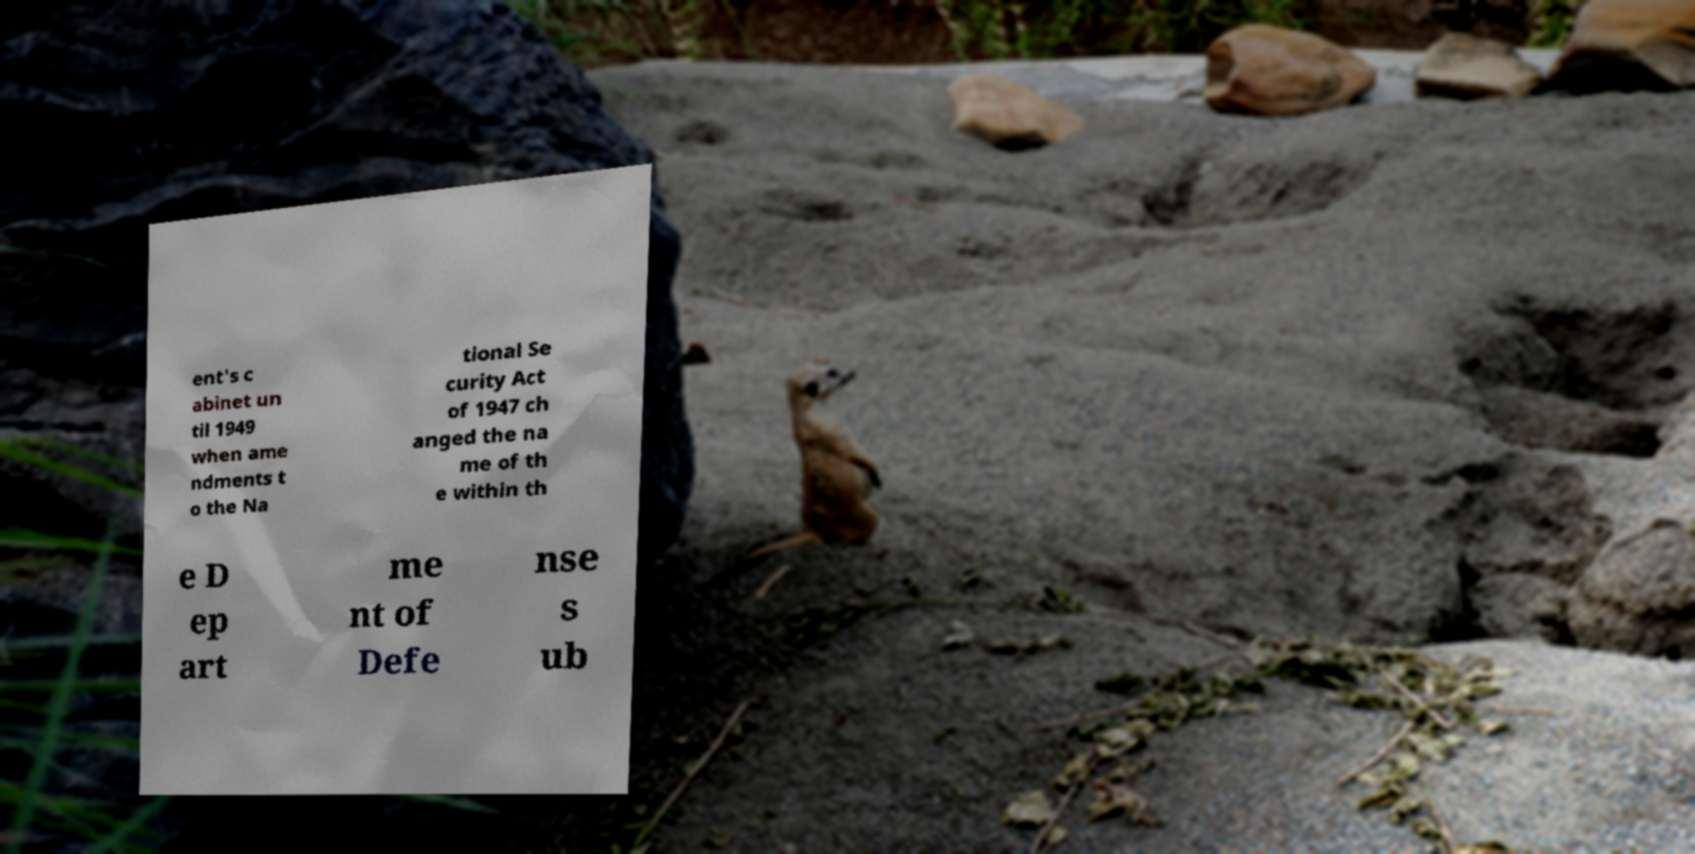Could you assist in decoding the text presented in this image and type it out clearly? ent's c abinet un til 1949 when ame ndments t o the Na tional Se curity Act of 1947 ch anged the na me of th e within th e D ep art me nt of Defe nse s ub 